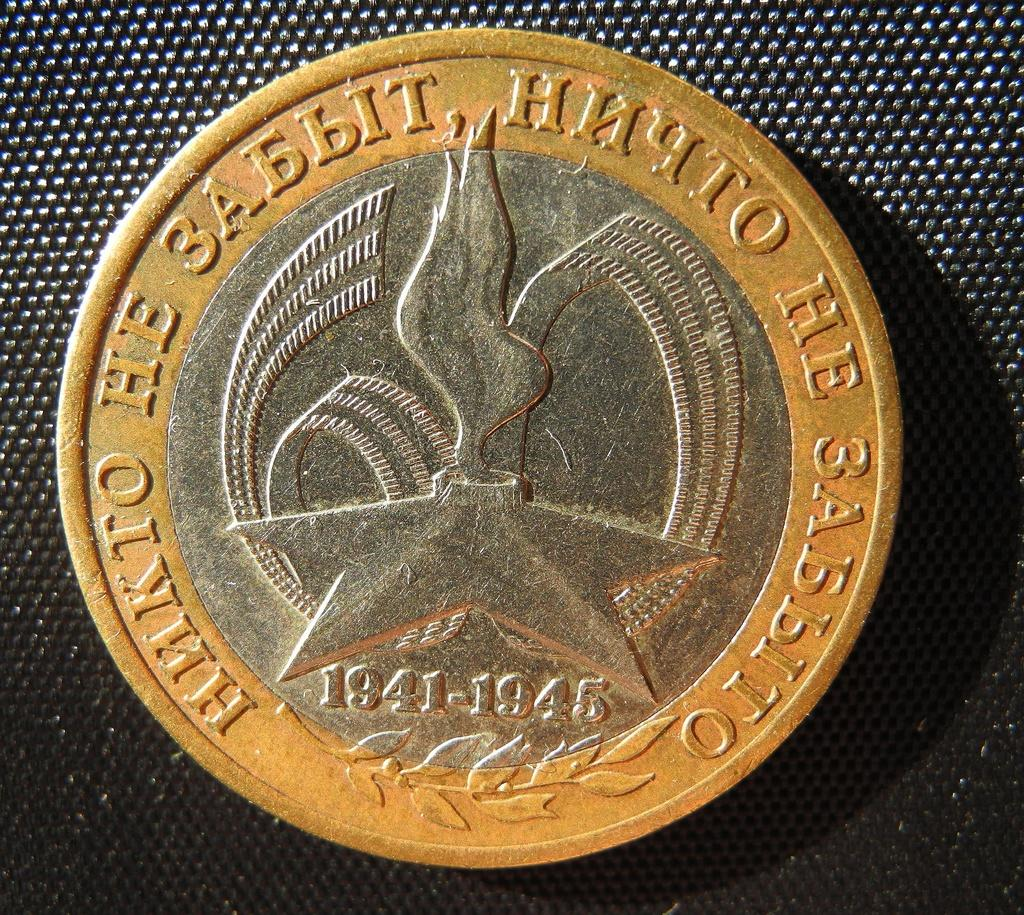<image>
Provide a brief description of the given image. a coin printed in Cyrillic with the dates 1941-1945 